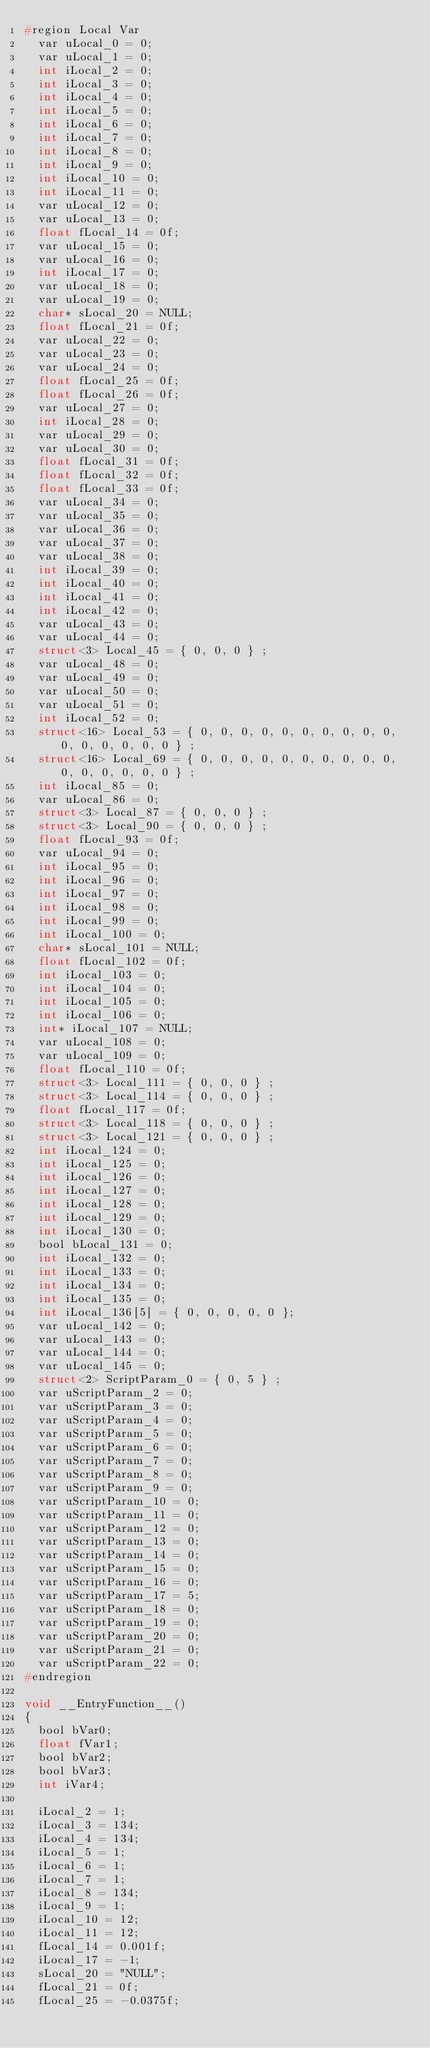<code> <loc_0><loc_0><loc_500><loc_500><_C_>#region Local Var
	var uLocal_0 = 0;
	var uLocal_1 = 0;
	int iLocal_2 = 0;
	int iLocal_3 = 0;
	int iLocal_4 = 0;
	int iLocal_5 = 0;
	int iLocal_6 = 0;
	int iLocal_7 = 0;
	int iLocal_8 = 0;
	int iLocal_9 = 0;
	int iLocal_10 = 0;
	int iLocal_11 = 0;
	var uLocal_12 = 0;
	var uLocal_13 = 0;
	float fLocal_14 = 0f;
	var uLocal_15 = 0;
	var uLocal_16 = 0;
	int iLocal_17 = 0;
	var uLocal_18 = 0;
	var uLocal_19 = 0;
	char* sLocal_20 = NULL;
	float fLocal_21 = 0f;
	var uLocal_22 = 0;
	var uLocal_23 = 0;
	var uLocal_24 = 0;
	float fLocal_25 = 0f;
	float fLocal_26 = 0f;
	var uLocal_27 = 0;
	int iLocal_28 = 0;
	var uLocal_29 = 0;
	var uLocal_30 = 0;
	float fLocal_31 = 0f;
	float fLocal_32 = 0f;
	float fLocal_33 = 0f;
	var uLocal_34 = 0;
	var uLocal_35 = 0;
	var uLocal_36 = 0;
	var uLocal_37 = 0;
	var uLocal_38 = 0;
	int iLocal_39 = 0;
	int iLocal_40 = 0;
	int iLocal_41 = 0;
	int iLocal_42 = 0;
	var uLocal_43 = 0;
	var uLocal_44 = 0;
	struct<3> Local_45 = { 0, 0, 0 } ;
	var uLocal_48 = 0;
	var uLocal_49 = 0;
	var uLocal_50 = 0;
	var uLocal_51 = 0;
	int iLocal_52 = 0;
	struct<16> Local_53 = { 0, 0, 0, 0, 0, 0, 0, 0, 0, 0, 0, 0, 0, 0, 0, 0 } ;
	struct<16> Local_69 = { 0, 0, 0, 0, 0, 0, 0, 0, 0, 0, 0, 0, 0, 0, 0, 0 } ;
	int iLocal_85 = 0;
	var uLocal_86 = 0;
	struct<3> Local_87 = { 0, 0, 0 } ;
	struct<3> Local_90 = { 0, 0, 0 } ;
	float fLocal_93 = 0f;
	var uLocal_94 = 0;
	int iLocal_95 = 0;
	int iLocal_96 = 0;
	int iLocal_97 = 0;
	int iLocal_98 = 0;
	int iLocal_99 = 0;
	int iLocal_100 = 0;
	char* sLocal_101 = NULL;
	float fLocal_102 = 0f;
	int iLocal_103 = 0;
	int iLocal_104 = 0;
	int iLocal_105 = 0;
	int iLocal_106 = 0;
	int* iLocal_107 = NULL;
	var uLocal_108 = 0;
	var uLocal_109 = 0;
	float fLocal_110 = 0f;
	struct<3> Local_111 = { 0, 0, 0 } ;
	struct<3> Local_114 = { 0, 0, 0 } ;
	float fLocal_117 = 0f;
	struct<3> Local_118 = { 0, 0, 0 } ;
	struct<3> Local_121 = { 0, 0, 0 } ;
	int iLocal_124 = 0;
	int iLocal_125 = 0;
	int iLocal_126 = 0;
	int iLocal_127 = 0;
	int iLocal_128 = 0;
	int iLocal_129 = 0;
	int iLocal_130 = 0;
	bool bLocal_131 = 0;
	int iLocal_132 = 0;
	int iLocal_133 = 0;
	int iLocal_134 = 0;
	int iLocal_135 = 0;
	int iLocal_136[5] = { 0, 0, 0, 0, 0 };
	var uLocal_142 = 0;
	var uLocal_143 = 0;
	var uLocal_144 = 0;
	var uLocal_145 = 0;
	struct<2> ScriptParam_0 = { 0, 5 } ;
	var uScriptParam_2 = 0;
	var uScriptParam_3 = 0;
	var uScriptParam_4 = 0;
	var uScriptParam_5 = 0;
	var uScriptParam_6 = 0;
	var uScriptParam_7 = 0;
	var uScriptParam_8 = 0;
	var uScriptParam_9 = 0;
	var uScriptParam_10 = 0;
	var uScriptParam_11 = 0;
	var uScriptParam_12 = 0;
	var uScriptParam_13 = 0;
	var uScriptParam_14 = 0;
	var uScriptParam_15 = 0;
	var uScriptParam_16 = 0;
	var uScriptParam_17 = 5;
	var uScriptParam_18 = 0;
	var uScriptParam_19 = 0;
	var uScriptParam_20 = 0;
	var uScriptParam_21 = 0;
	var uScriptParam_22 = 0;
#endregion

void __EntryFunction__()
{
	bool bVar0;
	float fVar1;
	bool bVar2;
	bool bVar3;
	int iVar4;
	
	iLocal_2 = 1;
	iLocal_3 = 134;
	iLocal_4 = 134;
	iLocal_5 = 1;
	iLocal_6 = 1;
	iLocal_7 = 1;
	iLocal_8 = 134;
	iLocal_9 = 1;
	iLocal_10 = 12;
	iLocal_11 = 12;
	fLocal_14 = 0.001f;
	iLocal_17 = -1;
	sLocal_20 = "NULL";
	fLocal_21 = 0f;
	fLocal_25 = -0.0375f;</code> 